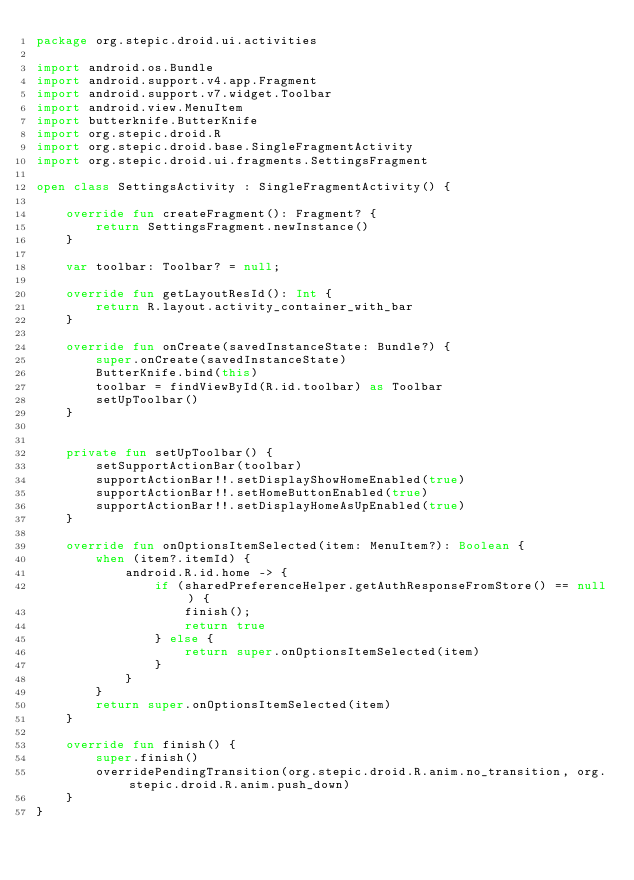<code> <loc_0><loc_0><loc_500><loc_500><_Kotlin_>package org.stepic.droid.ui.activities

import android.os.Bundle
import android.support.v4.app.Fragment
import android.support.v7.widget.Toolbar
import android.view.MenuItem
import butterknife.ButterKnife
import org.stepic.droid.R
import org.stepic.droid.base.SingleFragmentActivity
import org.stepic.droid.ui.fragments.SettingsFragment

open class SettingsActivity : SingleFragmentActivity() {

    override fun createFragment(): Fragment? {
        return SettingsFragment.newInstance()
    }

    var toolbar: Toolbar? = null;

    override fun getLayoutResId(): Int {
        return R.layout.activity_container_with_bar
    }

    override fun onCreate(savedInstanceState: Bundle?) {
        super.onCreate(savedInstanceState)
        ButterKnife.bind(this)
        toolbar = findViewById(R.id.toolbar) as Toolbar
        setUpToolbar()
    }


    private fun setUpToolbar() {
        setSupportActionBar(toolbar)
        supportActionBar!!.setDisplayShowHomeEnabled(true)
        supportActionBar!!.setHomeButtonEnabled(true)
        supportActionBar!!.setDisplayHomeAsUpEnabled(true)
    }

    override fun onOptionsItemSelected(item: MenuItem?): Boolean {
        when (item?.itemId) {
            android.R.id.home -> {
                if (sharedPreferenceHelper.getAuthResponseFromStore() == null) {
                    finish();
                    return true
                } else {
                    return super.onOptionsItemSelected(item)
                }
            }
        }
        return super.onOptionsItemSelected(item)
    }

    override fun finish() {
        super.finish()
        overridePendingTransition(org.stepic.droid.R.anim.no_transition, org.stepic.droid.R.anim.push_down)
    }
}</code> 